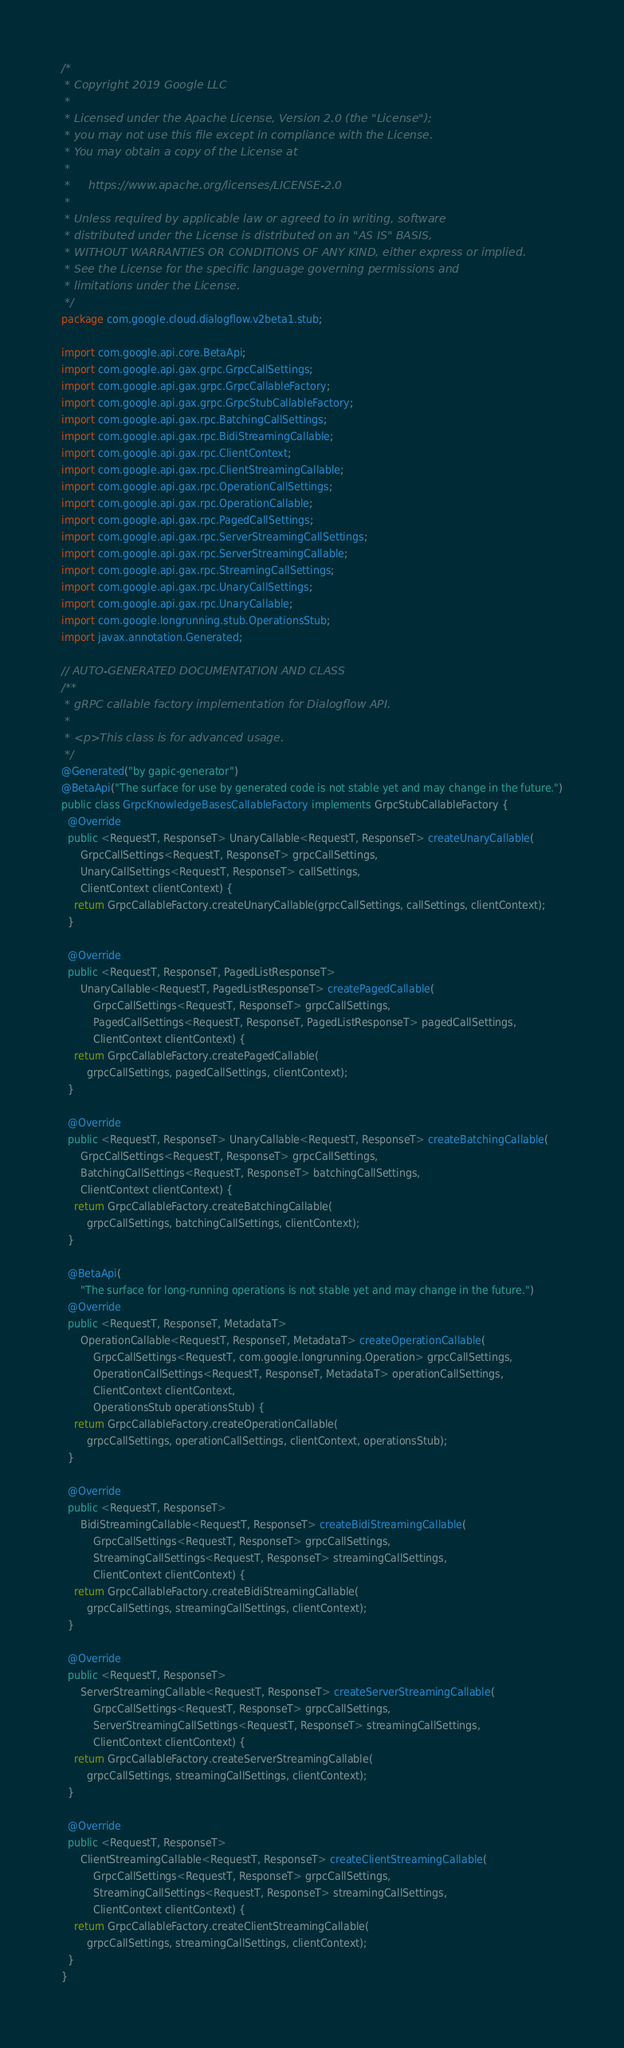Convert code to text. <code><loc_0><loc_0><loc_500><loc_500><_Java_>/*
 * Copyright 2019 Google LLC
 *
 * Licensed under the Apache License, Version 2.0 (the "License");
 * you may not use this file except in compliance with the License.
 * You may obtain a copy of the License at
 *
 *     https://www.apache.org/licenses/LICENSE-2.0
 *
 * Unless required by applicable law or agreed to in writing, software
 * distributed under the License is distributed on an "AS IS" BASIS,
 * WITHOUT WARRANTIES OR CONDITIONS OF ANY KIND, either express or implied.
 * See the License for the specific language governing permissions and
 * limitations under the License.
 */
package com.google.cloud.dialogflow.v2beta1.stub;

import com.google.api.core.BetaApi;
import com.google.api.gax.grpc.GrpcCallSettings;
import com.google.api.gax.grpc.GrpcCallableFactory;
import com.google.api.gax.grpc.GrpcStubCallableFactory;
import com.google.api.gax.rpc.BatchingCallSettings;
import com.google.api.gax.rpc.BidiStreamingCallable;
import com.google.api.gax.rpc.ClientContext;
import com.google.api.gax.rpc.ClientStreamingCallable;
import com.google.api.gax.rpc.OperationCallSettings;
import com.google.api.gax.rpc.OperationCallable;
import com.google.api.gax.rpc.PagedCallSettings;
import com.google.api.gax.rpc.ServerStreamingCallSettings;
import com.google.api.gax.rpc.ServerStreamingCallable;
import com.google.api.gax.rpc.StreamingCallSettings;
import com.google.api.gax.rpc.UnaryCallSettings;
import com.google.api.gax.rpc.UnaryCallable;
import com.google.longrunning.stub.OperationsStub;
import javax.annotation.Generated;

// AUTO-GENERATED DOCUMENTATION AND CLASS
/**
 * gRPC callable factory implementation for Dialogflow API.
 *
 * <p>This class is for advanced usage.
 */
@Generated("by gapic-generator")
@BetaApi("The surface for use by generated code is not stable yet and may change in the future.")
public class GrpcKnowledgeBasesCallableFactory implements GrpcStubCallableFactory {
  @Override
  public <RequestT, ResponseT> UnaryCallable<RequestT, ResponseT> createUnaryCallable(
      GrpcCallSettings<RequestT, ResponseT> grpcCallSettings,
      UnaryCallSettings<RequestT, ResponseT> callSettings,
      ClientContext clientContext) {
    return GrpcCallableFactory.createUnaryCallable(grpcCallSettings, callSettings, clientContext);
  }

  @Override
  public <RequestT, ResponseT, PagedListResponseT>
      UnaryCallable<RequestT, PagedListResponseT> createPagedCallable(
          GrpcCallSettings<RequestT, ResponseT> grpcCallSettings,
          PagedCallSettings<RequestT, ResponseT, PagedListResponseT> pagedCallSettings,
          ClientContext clientContext) {
    return GrpcCallableFactory.createPagedCallable(
        grpcCallSettings, pagedCallSettings, clientContext);
  }

  @Override
  public <RequestT, ResponseT> UnaryCallable<RequestT, ResponseT> createBatchingCallable(
      GrpcCallSettings<RequestT, ResponseT> grpcCallSettings,
      BatchingCallSettings<RequestT, ResponseT> batchingCallSettings,
      ClientContext clientContext) {
    return GrpcCallableFactory.createBatchingCallable(
        grpcCallSettings, batchingCallSettings, clientContext);
  }

  @BetaApi(
      "The surface for long-running operations is not stable yet and may change in the future.")
  @Override
  public <RequestT, ResponseT, MetadataT>
      OperationCallable<RequestT, ResponseT, MetadataT> createOperationCallable(
          GrpcCallSettings<RequestT, com.google.longrunning.Operation> grpcCallSettings,
          OperationCallSettings<RequestT, ResponseT, MetadataT> operationCallSettings,
          ClientContext clientContext,
          OperationsStub operationsStub) {
    return GrpcCallableFactory.createOperationCallable(
        grpcCallSettings, operationCallSettings, clientContext, operationsStub);
  }

  @Override
  public <RequestT, ResponseT>
      BidiStreamingCallable<RequestT, ResponseT> createBidiStreamingCallable(
          GrpcCallSettings<RequestT, ResponseT> grpcCallSettings,
          StreamingCallSettings<RequestT, ResponseT> streamingCallSettings,
          ClientContext clientContext) {
    return GrpcCallableFactory.createBidiStreamingCallable(
        grpcCallSettings, streamingCallSettings, clientContext);
  }

  @Override
  public <RequestT, ResponseT>
      ServerStreamingCallable<RequestT, ResponseT> createServerStreamingCallable(
          GrpcCallSettings<RequestT, ResponseT> grpcCallSettings,
          ServerStreamingCallSettings<RequestT, ResponseT> streamingCallSettings,
          ClientContext clientContext) {
    return GrpcCallableFactory.createServerStreamingCallable(
        grpcCallSettings, streamingCallSettings, clientContext);
  }

  @Override
  public <RequestT, ResponseT>
      ClientStreamingCallable<RequestT, ResponseT> createClientStreamingCallable(
          GrpcCallSettings<RequestT, ResponseT> grpcCallSettings,
          StreamingCallSettings<RequestT, ResponseT> streamingCallSettings,
          ClientContext clientContext) {
    return GrpcCallableFactory.createClientStreamingCallable(
        grpcCallSettings, streamingCallSettings, clientContext);
  }
}
</code> 